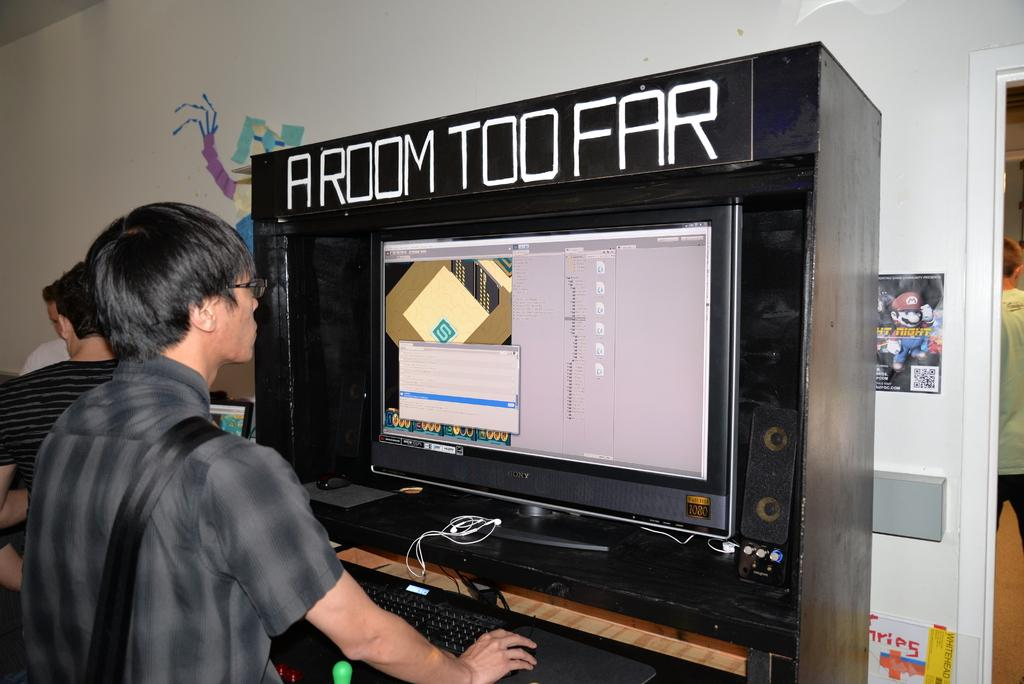<image>
Summarize the visual content of the image. A person is using a computer that is inside of a black booth. 